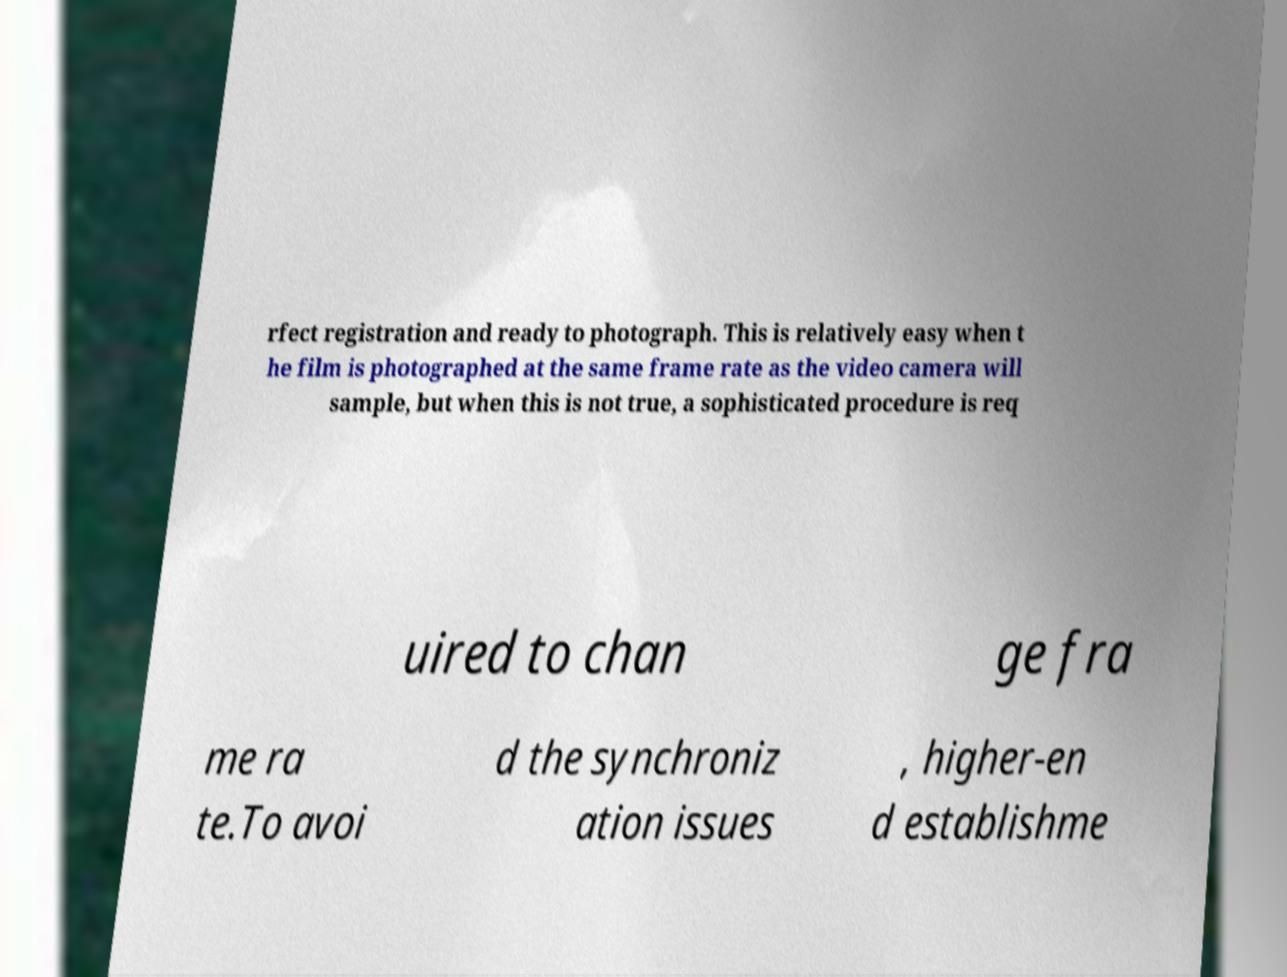Can you accurately transcribe the text from the provided image for me? rfect registration and ready to photograph. This is relatively easy when t he film is photographed at the same frame rate as the video camera will sample, but when this is not true, a sophisticated procedure is req uired to chan ge fra me ra te.To avoi d the synchroniz ation issues , higher-en d establishme 